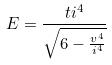<formula> <loc_0><loc_0><loc_500><loc_500>E = \frac { t i ^ { 4 } } { \sqrt { 6 - \frac { v ^ { 4 } } { i ^ { 4 } } } }</formula> 